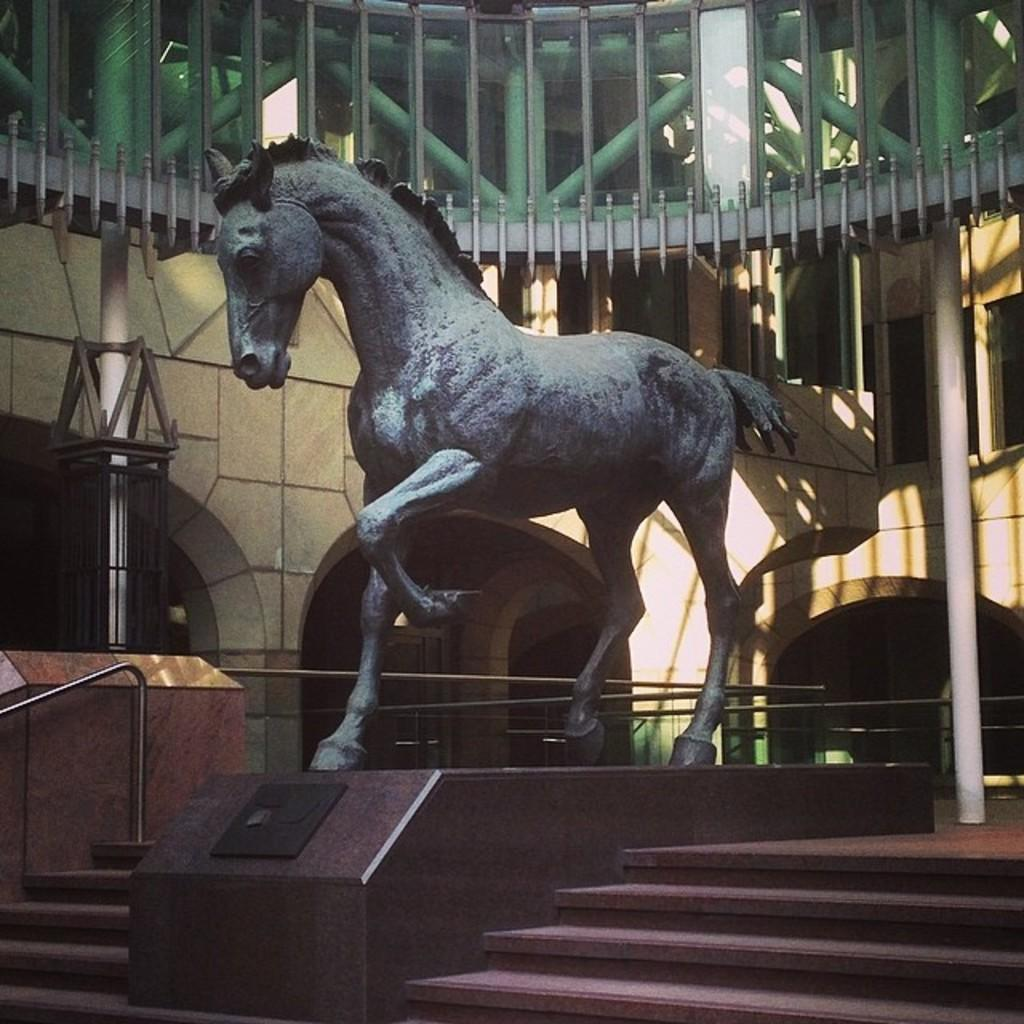What is the main subject in the image? There is a statue in the image. What type of structure can be seen in the image? There is a building with windows in the image. What material are the poles made of in the image? The poles in the image are made of metal. Can you describe any architectural features in the image? There is a staircase in the image. Reasoning: Let's think step by following the guidelines to produce the conversation. We start by identifying the main subject, specific subject in the image, which is the statue. Then, we describe other elements in the image, such as the building, metal poles, and staircase. Each question is designed to elicit a specific detail about the image that is known from the provided facts. Absurd Question/Answer: How does the watch roll down the stairs in the image? There is no watch or rolling action depicted in the image. 